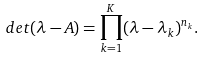<formula> <loc_0><loc_0><loc_500><loc_500>d e t ( \lambda - A ) = \prod _ { k = 1 } ^ { K } ( \lambda - \lambda _ { k } ) ^ { n _ { k } } .</formula> 